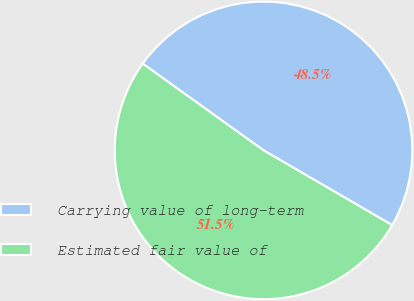Convert chart. <chart><loc_0><loc_0><loc_500><loc_500><pie_chart><fcel>Carrying value of long-term<fcel>Estimated fair value of<nl><fcel>48.47%<fcel>51.53%<nl></chart> 